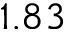<formula> <loc_0><loc_0><loc_500><loc_500>1 . 8 3</formula> 